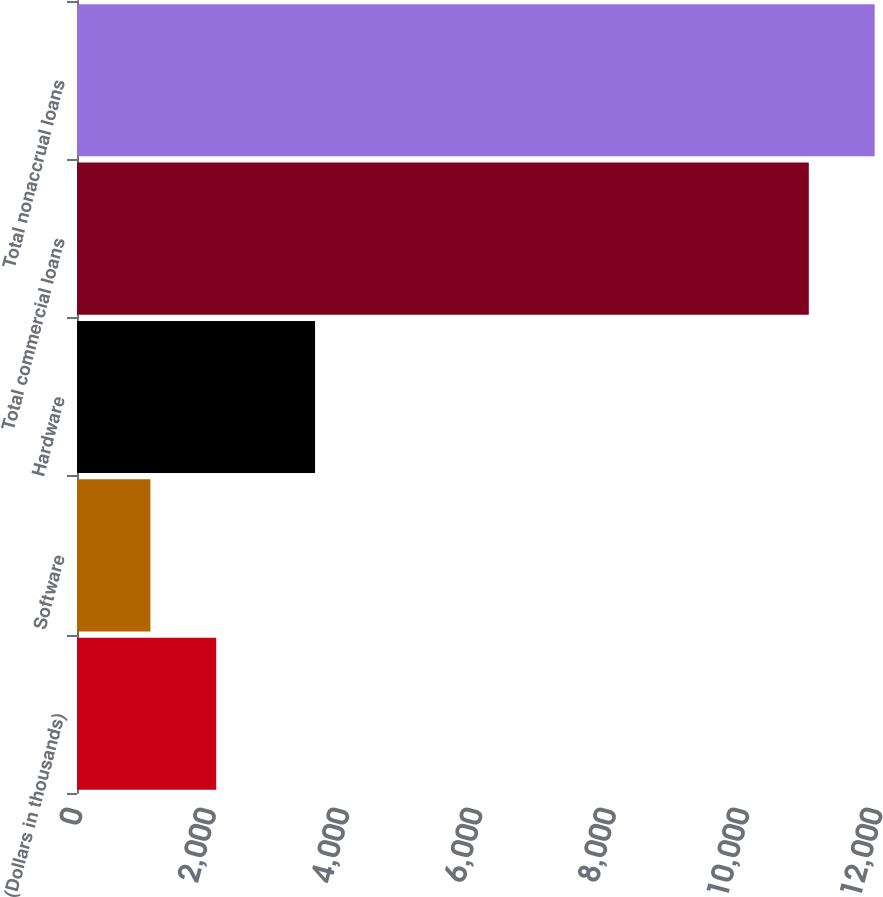Convert chart to OTSL. <chart><loc_0><loc_0><loc_500><loc_500><bar_chart><fcel>(Dollars in thousands)<fcel>Software<fcel>Hardware<fcel>Total commercial loans<fcel>Total nonaccrual loans<nl><fcel>2088.6<fcel>1101<fcel>3571<fcel>10977<fcel>11964.6<nl></chart> 